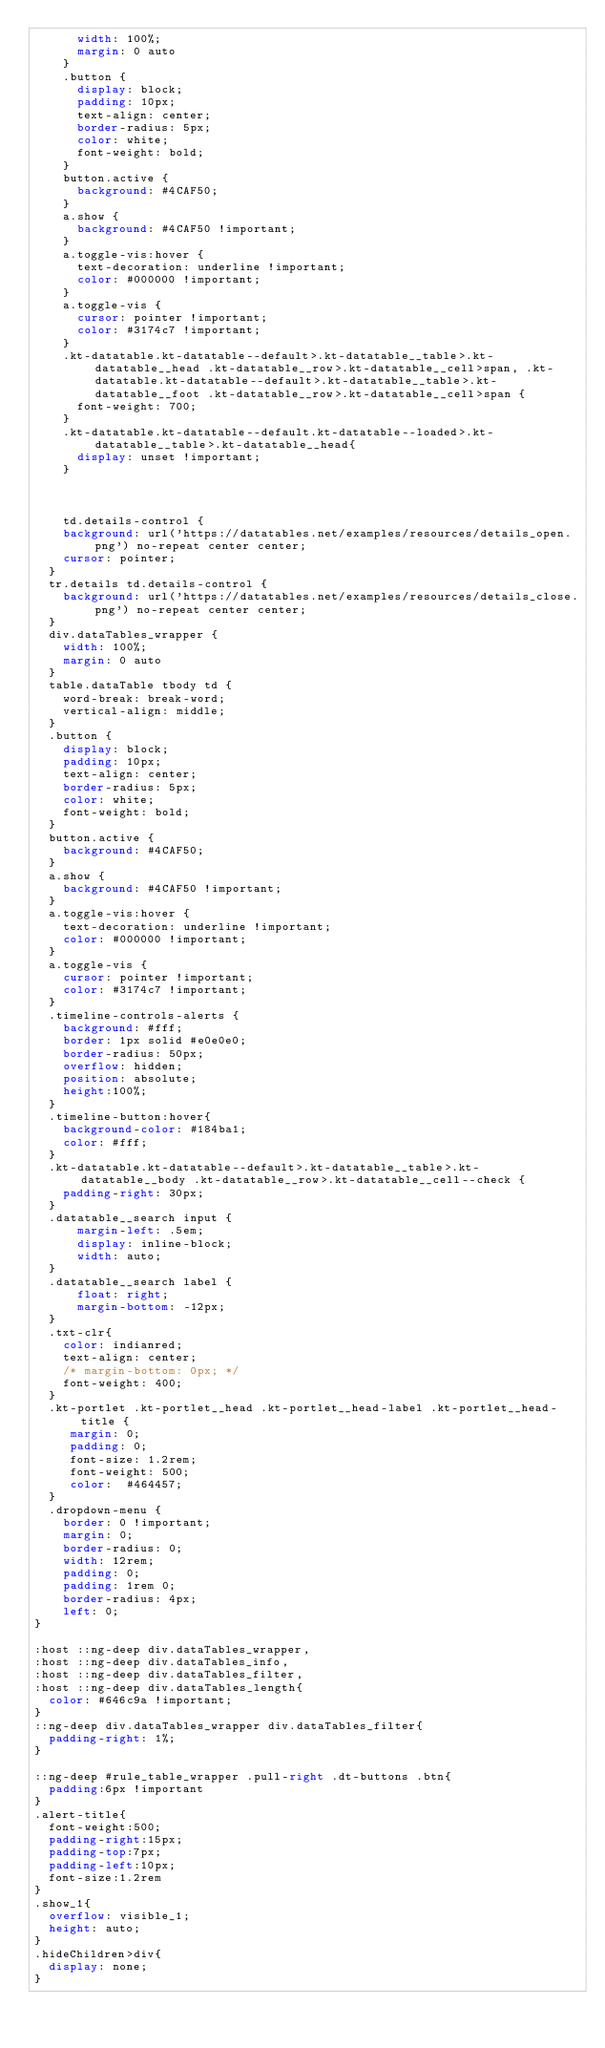<code> <loc_0><loc_0><loc_500><loc_500><_CSS_>      width: 100%;
      margin: 0 auto
    }
    .button {
      display: block;
      padding: 10px;
      text-align: center;
      border-radius: 5px;
      color: white;
      font-weight: bold;
    }
    button.active {
      background: #4CAF50;
    }
    a.show {
      background: #4CAF50 !important;
    }
    a.toggle-vis:hover {
      text-decoration: underline !important;
      color: #000000 !important;
    }
    a.toggle-vis {
      cursor: pointer !important;
      color: #3174c7 !important;
    }
    .kt-datatable.kt-datatable--default>.kt-datatable__table>.kt-datatable__head .kt-datatable__row>.kt-datatable__cell>span, .kt-datatable.kt-datatable--default>.kt-datatable__table>.kt-datatable__foot .kt-datatable__row>.kt-datatable__cell>span {
      font-weight: 700;
    }
    .kt-datatable.kt-datatable--default.kt-datatable--loaded>.kt-datatable__table>.kt-datatable__head{
      display: unset !important;
    }



    td.details-control {
    background: url('https://datatables.net/examples/resources/details_open.png') no-repeat center center;
    cursor: pointer;
  }
  tr.details td.details-control {
    background: url('https://datatables.net/examples/resources/details_close.png') no-repeat center center;
  }
  div.dataTables_wrapper {
    width: 100%;
    margin: 0 auto
  }
  table.dataTable tbody td {
    word-break: break-word;
    vertical-align: middle;
  }
  .button {
    display: block;
    padding: 10px;
    text-align: center;
    border-radius: 5px;
    color: white;
    font-weight: bold;
  }
  button.active {
    background: #4CAF50;
  }
  a.show {
    background: #4CAF50 !important;
  }
  a.toggle-vis:hover {
    text-decoration: underline !important;
    color: #000000 !important;
  }
  a.toggle-vis {
    cursor: pointer !important;
    color: #3174c7 !important;
  }
  .timeline-controls-alerts {
    background: #fff;
    border: 1px solid #e0e0e0;
    border-radius: 50px;
    overflow: hidden;
    position: absolute;
    height:100%;
  }
  .timeline-button:hover{
    background-color: #184ba1;
    color: #fff;
  }
  .kt-datatable.kt-datatable--default>.kt-datatable__table>.kt-datatable__body .kt-datatable__row>.kt-datatable__cell--check {
    padding-right: 30px;
  }
  .datatable__search input {
      margin-left: .5em;
      display: inline-block;
      width: auto;
  }
  .datatable__search label {
      float: right;
      margin-bottom: -12px;
  }
  .txt-clr{
    color: indianred;
    text-align: center;
    /* margin-bottom: 0px; */
    font-weight: 400;
  }
  .kt-portlet .kt-portlet__head .kt-portlet__head-label .kt-portlet__head-title {
     margin: 0;
     padding: 0;
     font-size: 1.2rem;
     font-weight: 500;
     color:  #464457;
  }
  .dropdown-menu {
    border: 0 !important;
    margin: 0;
    border-radius: 0;
    width: 12rem;
    padding: 0;
    padding: 1rem 0;
    border-radius: 4px;
    left: 0;
}

:host ::ng-deep div.dataTables_wrapper,
:host ::ng-deep div.dataTables_info,
:host ::ng-deep div.dataTables_filter,
:host ::ng-deep div.dataTables_length{
  color: #646c9a !important;
}
::ng-deep div.dataTables_wrapper div.dataTables_filter{
  padding-right: 1%;
}

::ng-deep #rule_table_wrapper .pull-right .dt-buttons .btn{
  padding:6px !important
}
.alert-title{
  font-weight:500;
  padding-right:15px;
  padding-top:7px;
  padding-left:10px;
  font-size:1.2rem
}
.show_1{
  overflow: visible_1;
  height: auto;
}
.hideChildren>div{
  display: none;
}</code> 